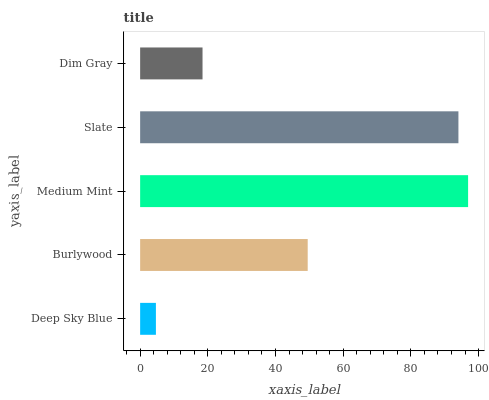Is Deep Sky Blue the minimum?
Answer yes or no. Yes. Is Medium Mint the maximum?
Answer yes or no. Yes. Is Burlywood the minimum?
Answer yes or no. No. Is Burlywood the maximum?
Answer yes or no. No. Is Burlywood greater than Deep Sky Blue?
Answer yes or no. Yes. Is Deep Sky Blue less than Burlywood?
Answer yes or no. Yes. Is Deep Sky Blue greater than Burlywood?
Answer yes or no. No. Is Burlywood less than Deep Sky Blue?
Answer yes or no. No. Is Burlywood the high median?
Answer yes or no. Yes. Is Burlywood the low median?
Answer yes or no. Yes. Is Dim Gray the high median?
Answer yes or no. No. Is Dim Gray the low median?
Answer yes or no. No. 